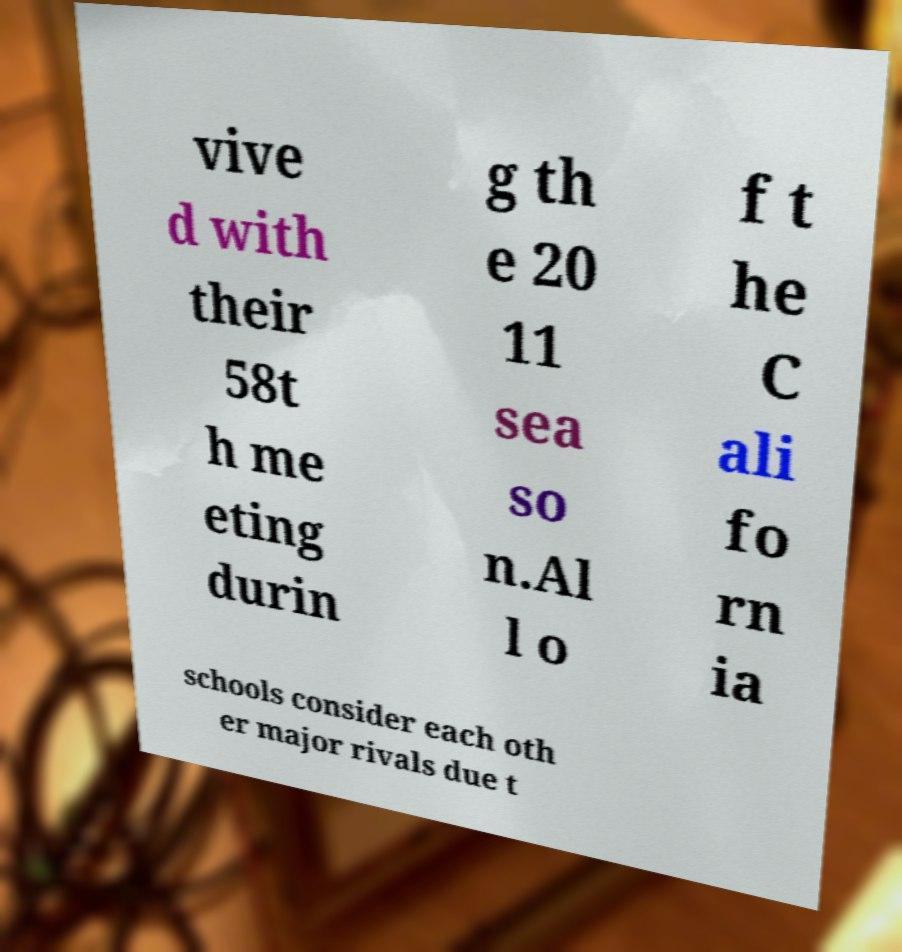Can you accurately transcribe the text from the provided image for me? vive d with their 58t h me eting durin g th e 20 11 sea so n.Al l o f t he C ali fo rn ia schools consider each oth er major rivals due t 